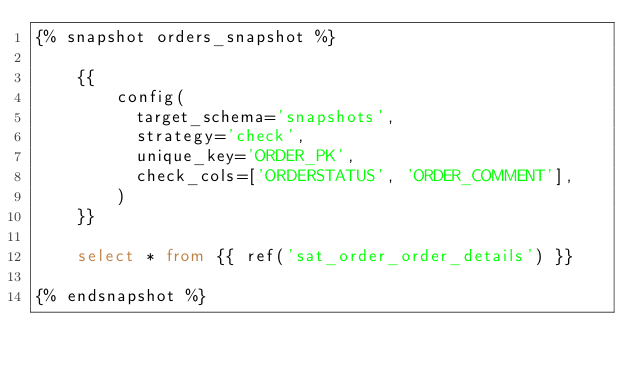<code> <loc_0><loc_0><loc_500><loc_500><_SQL_>{% snapshot orders_snapshot %}

    {{
        config(
          target_schema='snapshots',
          strategy='check',
          unique_key='ORDER_PK',
          check_cols=['ORDERSTATUS', 'ORDER_COMMENT'],
        )
    }}

    select * from {{ ref('sat_order_order_details') }}

{% endsnapshot %}</code> 